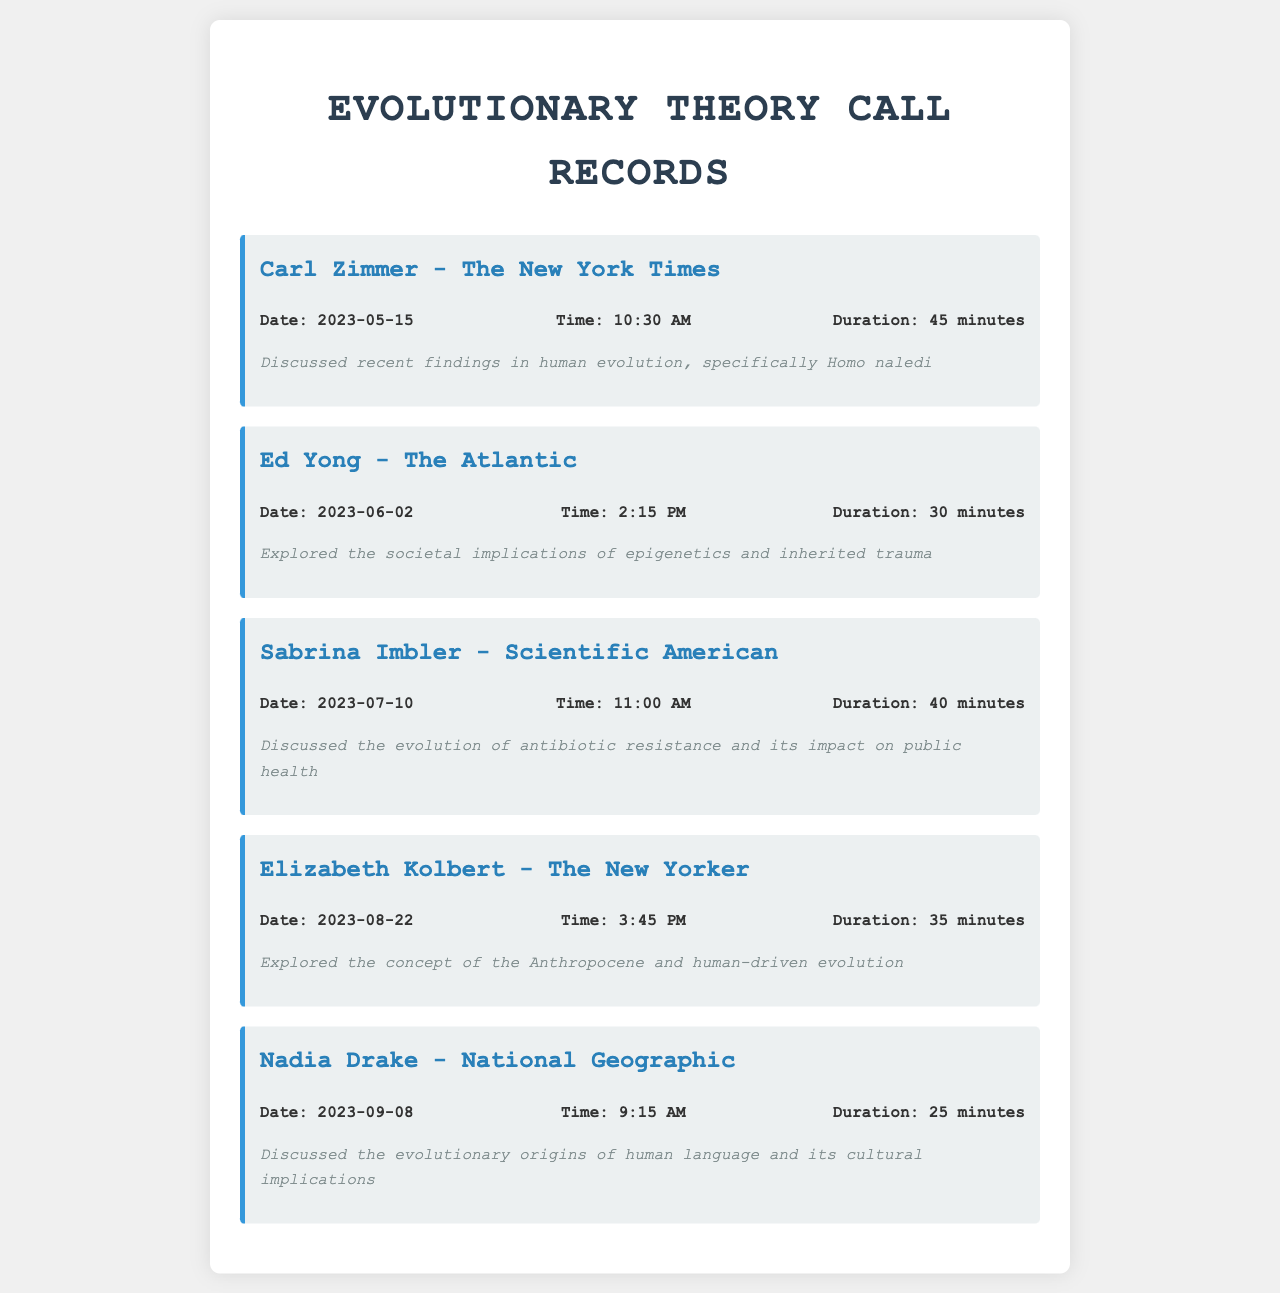What is the date of the call with Carl Zimmer? The date of the call with Carl Zimmer is clearly stated in the document as May 15, 2023.
Answer: May 15, 2023 How long was the call with Ed Yong? The duration of the call with Ed Yong is mentioned in the document as 30 minutes.
Answer: 30 minutes What topic did Sabrina Imbler discuss? The document indicates that Sabrina Imbler discussed the evolution of antibiotic resistance and its impact on public health.
Answer: Evolution of antibiotic resistance Who was the journalist from The New Yorker? The document lists Elizabeth Kolbert as the journalist from The New Yorker.
Answer: Elizabeth Kolbert When did the call with Nadia Drake take place? Nadia Drake's call date is provided in the document as September 8, 2023.
Answer: September 8, 2023 What is the main focus of the call with Elizabeth Kolbert? The document specifies that the main focus of the call was exploring the concept of the Anthropocene and human-driven evolution.
Answer: The Anthropocene and human-driven evolution How many calls were made in total? The document lists a total of five calls made to various journalists.
Answer: Five What is a common theme discussed across the calls? The document indicates that the calls frequently discuss topics related to evolutionary theory and its societal implications.
Answer: Evolutionary theory and societal implications 